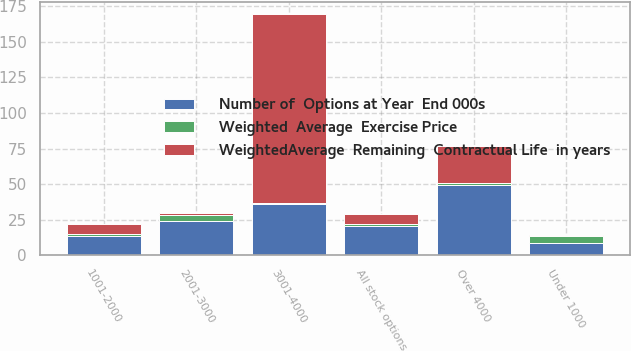<chart> <loc_0><loc_0><loc_500><loc_500><stacked_bar_chart><ecel><fcel>Under 1000<fcel>1001-2000<fcel>2001-3000<fcel>3001-4000<fcel>Over 4000<fcel>All stock options<nl><fcel>WeightedAverage  Remaining  Contractual Life  in years<fcel>1<fcel>6.795<fcel>1<fcel>133<fcel>26<fcel>6.795<nl><fcel>Number of  Options at Year  End 000s<fcel>8.59<fcel>13.42<fcel>24.41<fcel>36.38<fcel>49.46<fcel>20.72<nl><fcel>Weighted  Average  Exercise Price<fcel>5<fcel>1.6<fcel>4<fcel>0.3<fcel>1.1<fcel>1.3<nl></chart> 